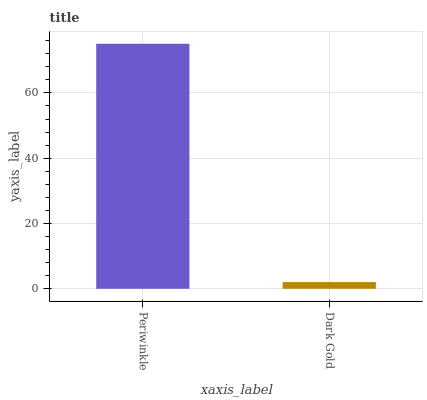Is Dark Gold the maximum?
Answer yes or no. No. Is Periwinkle greater than Dark Gold?
Answer yes or no. Yes. Is Dark Gold less than Periwinkle?
Answer yes or no. Yes. Is Dark Gold greater than Periwinkle?
Answer yes or no. No. Is Periwinkle less than Dark Gold?
Answer yes or no. No. Is Periwinkle the high median?
Answer yes or no. Yes. Is Dark Gold the low median?
Answer yes or no. Yes. Is Dark Gold the high median?
Answer yes or no. No. Is Periwinkle the low median?
Answer yes or no. No. 